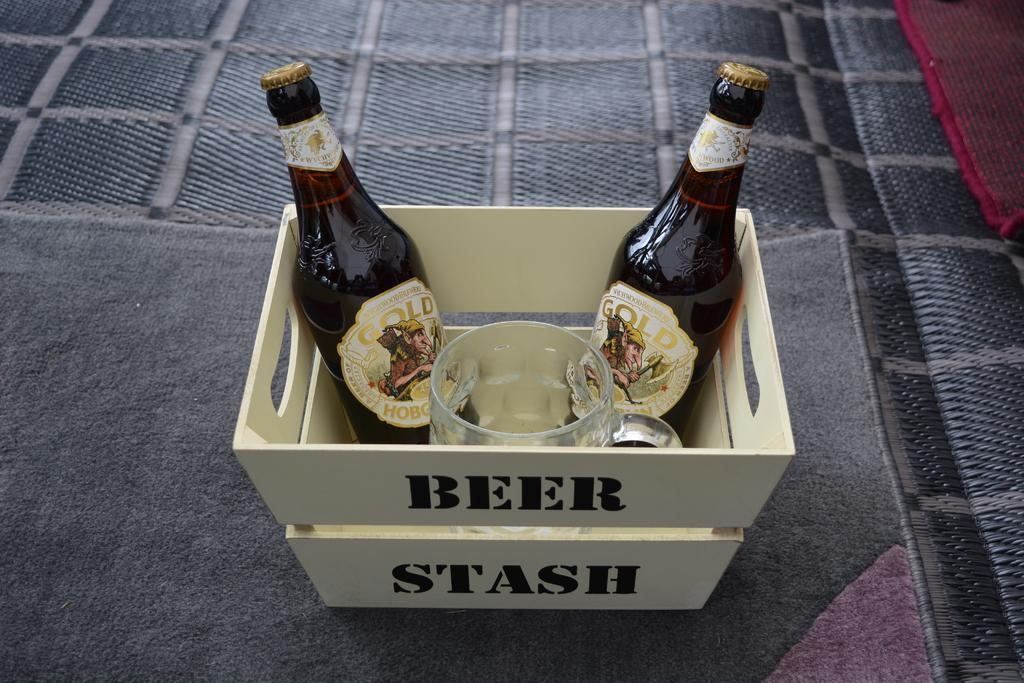<image>
Create a compact narrative representing the image presented. the word beer is on a wooden case 